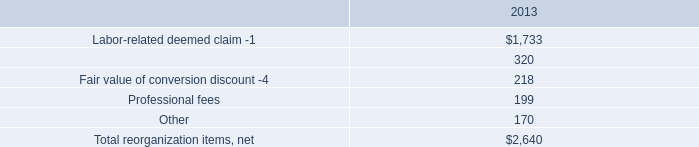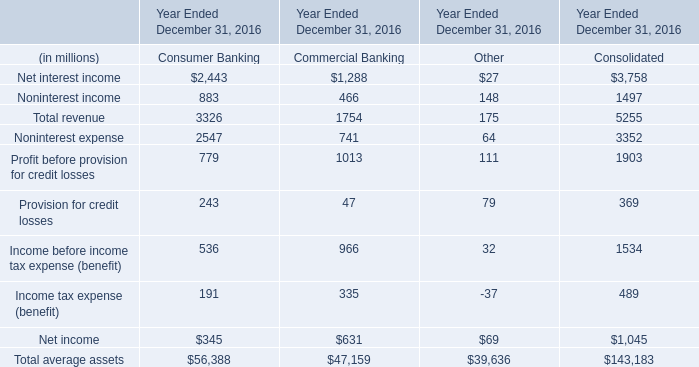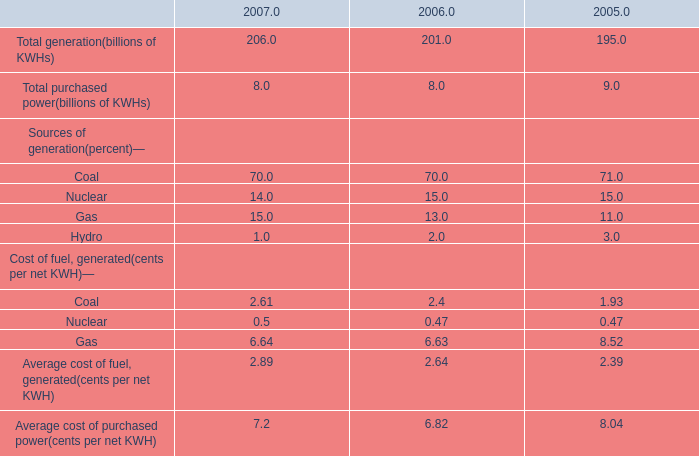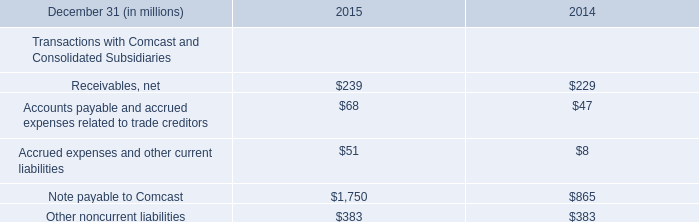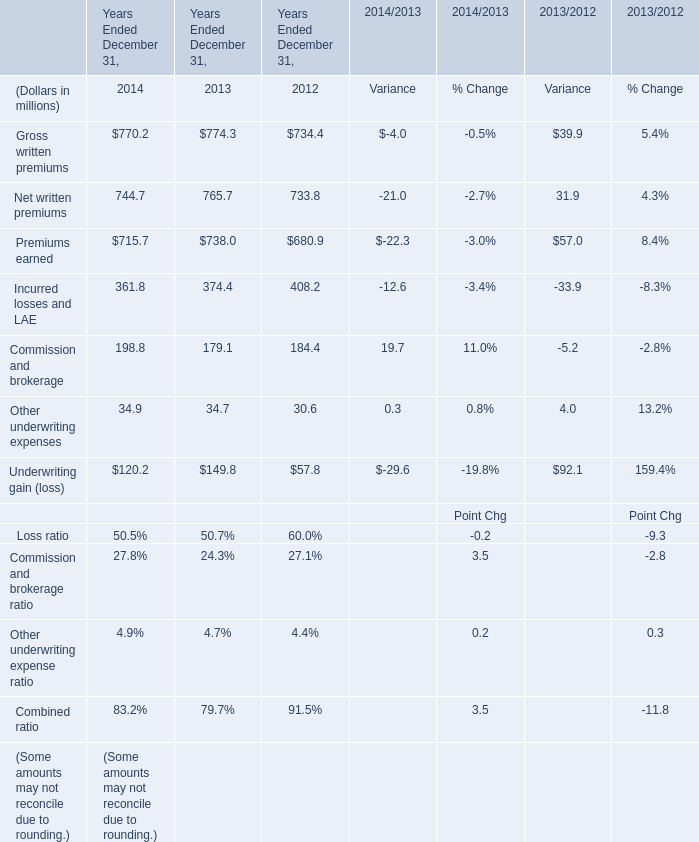In which section the sum of revenue has the highest value? 
Answer: Consumer Bank. 